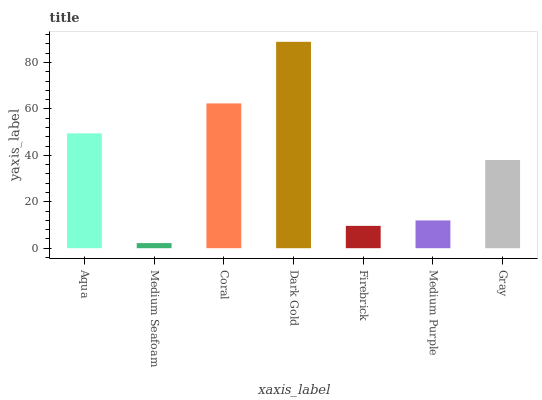Is Coral the minimum?
Answer yes or no. No. Is Coral the maximum?
Answer yes or no. No. Is Coral greater than Medium Seafoam?
Answer yes or no. Yes. Is Medium Seafoam less than Coral?
Answer yes or no. Yes. Is Medium Seafoam greater than Coral?
Answer yes or no. No. Is Coral less than Medium Seafoam?
Answer yes or no. No. Is Gray the high median?
Answer yes or no. Yes. Is Gray the low median?
Answer yes or no. Yes. Is Coral the high median?
Answer yes or no. No. Is Aqua the low median?
Answer yes or no. No. 